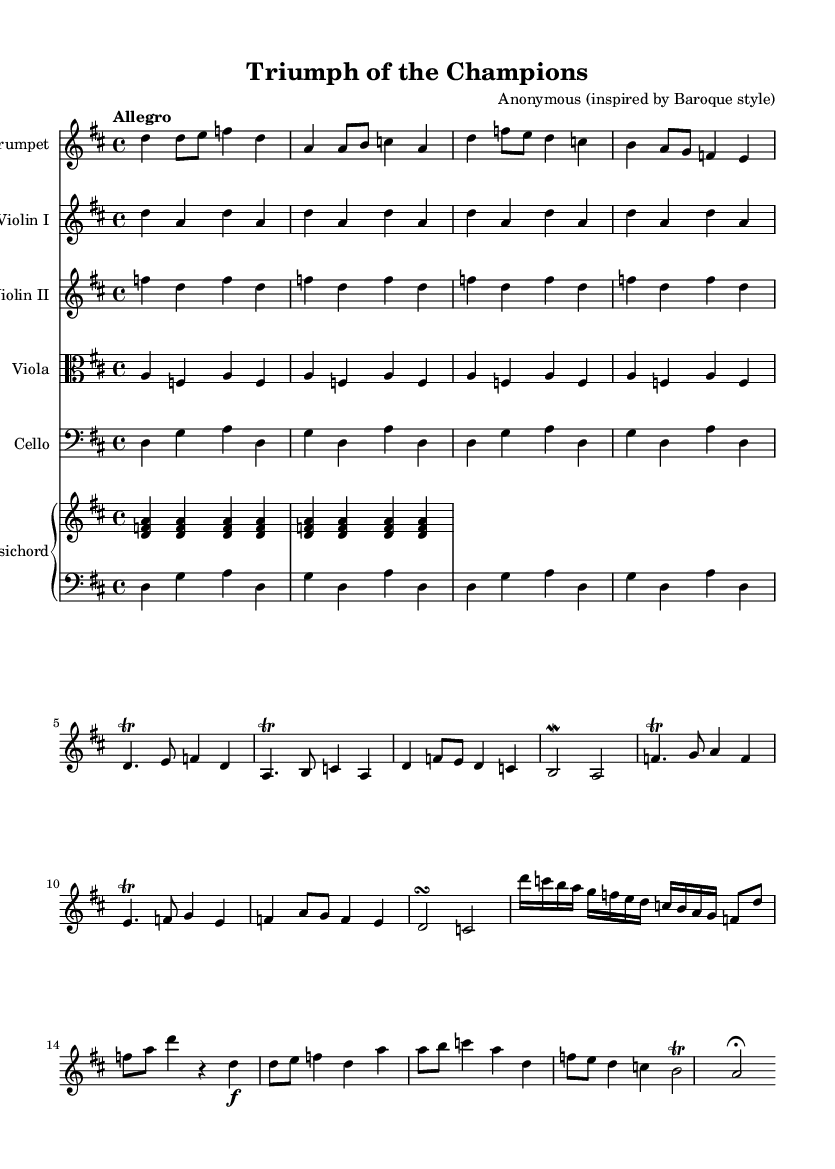What is the key signature of this music? The key signature is D major, which has two sharps (F# and C#). This can be determined by looking at the key signature indicated at the beginning of the score.
Answer: D major What is the time signature of this piece? The time signature is 4/4, which means there are four beats in a measure and the quarter note gets one beat. This is indicated at the beginning of the score next to the key signature.
Answer: 4/4 What is the specified tempo for the piece? The tempo is indicated as "Allegro," which typically means a fast and lively pace. This can be found in the tempo marking at the beginning of the score.
Answer: Allegro How many instruments are featured in this piece? There are five distinct instruments featured in the piece: Trumpet, Violin I, Violin II, Viola, and Cello (plus Harpsichord accompaniment). This is apparent from the labeled staves in the score.
Answer: Five Is there a solo section for the trumpet, and if so, where does it begin? Yes, there is a solo section for the trumpet, which begins in measure 11. This can be identified by the shift in the music specific to the trumpet part and the absence of other accompaniment for some measures.
Answer: Measure 11 What form does this Baroque piece likely exhibit, based on its structure? The piece likely exhibits a concerto form, which is characterized by the prominent soloist (in this case, the trumpet) contrasted against orchestral accompaniment. This can be inferred from the presence of a solo trumpet part and the accompaniment from the other instruments.
Answer: Concerto 